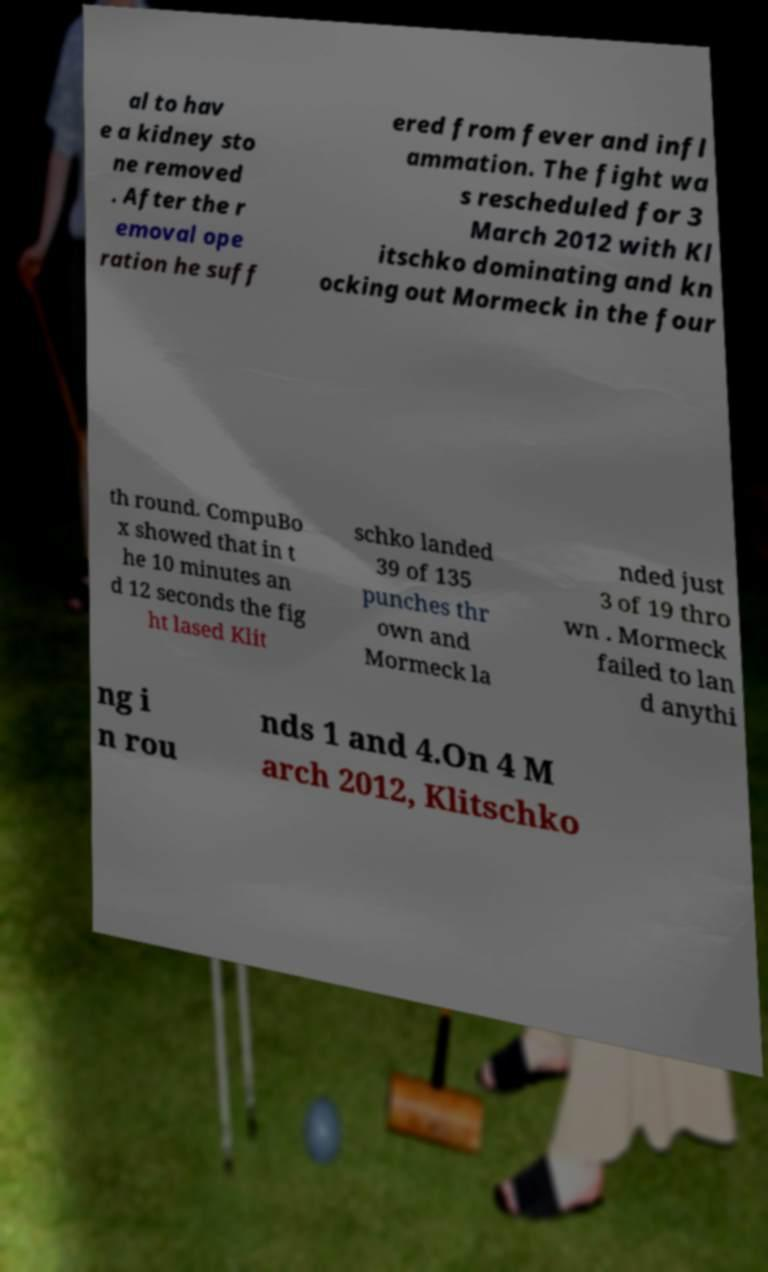There's text embedded in this image that I need extracted. Can you transcribe it verbatim? al to hav e a kidney sto ne removed . After the r emoval ope ration he suff ered from fever and infl ammation. The fight wa s rescheduled for 3 March 2012 with Kl itschko dominating and kn ocking out Mormeck in the four th round. CompuBo x showed that in t he 10 minutes an d 12 seconds the fig ht lased Klit schko landed 39 of 135 punches thr own and Mormeck la nded just 3 of 19 thro wn . Mormeck failed to lan d anythi ng i n rou nds 1 and 4.On 4 M arch 2012, Klitschko 